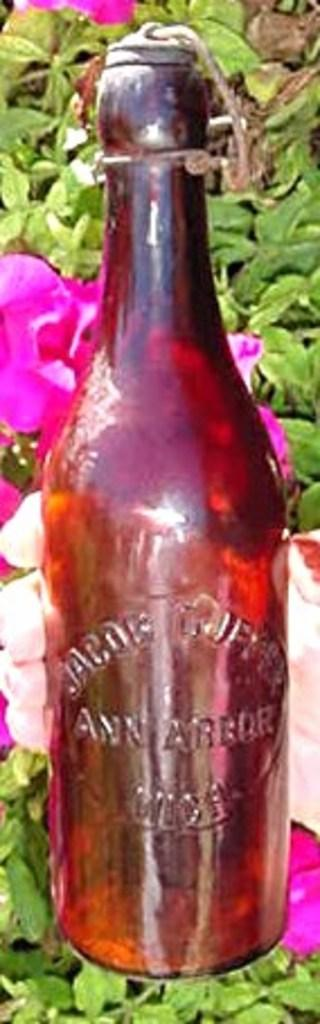What object in the image appears to be empty? There is an empty bottle in the image. How is the bottle sealed? The bottle is sealed with a cork. What type of plant material can be seen in the image? There are leaves and flowers in the image. What type of kitten is sitting on the owner's lap in the image? There is no kitten or owner present in the image; it only features an empty bottle, leaves, and flowers. 